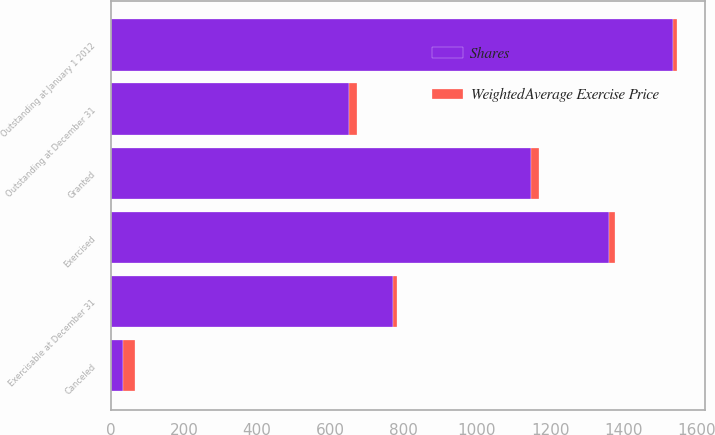<chart> <loc_0><loc_0><loc_500><loc_500><stacked_bar_chart><ecel><fcel>Outstanding at January 1 2012<fcel>Granted<fcel>Exercised<fcel>Canceled<fcel>Outstanding at December 31<fcel>Exercisable at December 31<nl><fcel>Shares<fcel>1536<fcel>1148<fcel>1362<fcel>34<fcel>652<fcel>770<nl><fcel>WeightedAverage Exercise Price<fcel>9.3<fcel>22.17<fcel>15.42<fcel>32.26<fcel>19.99<fcel>10.97<nl></chart> 